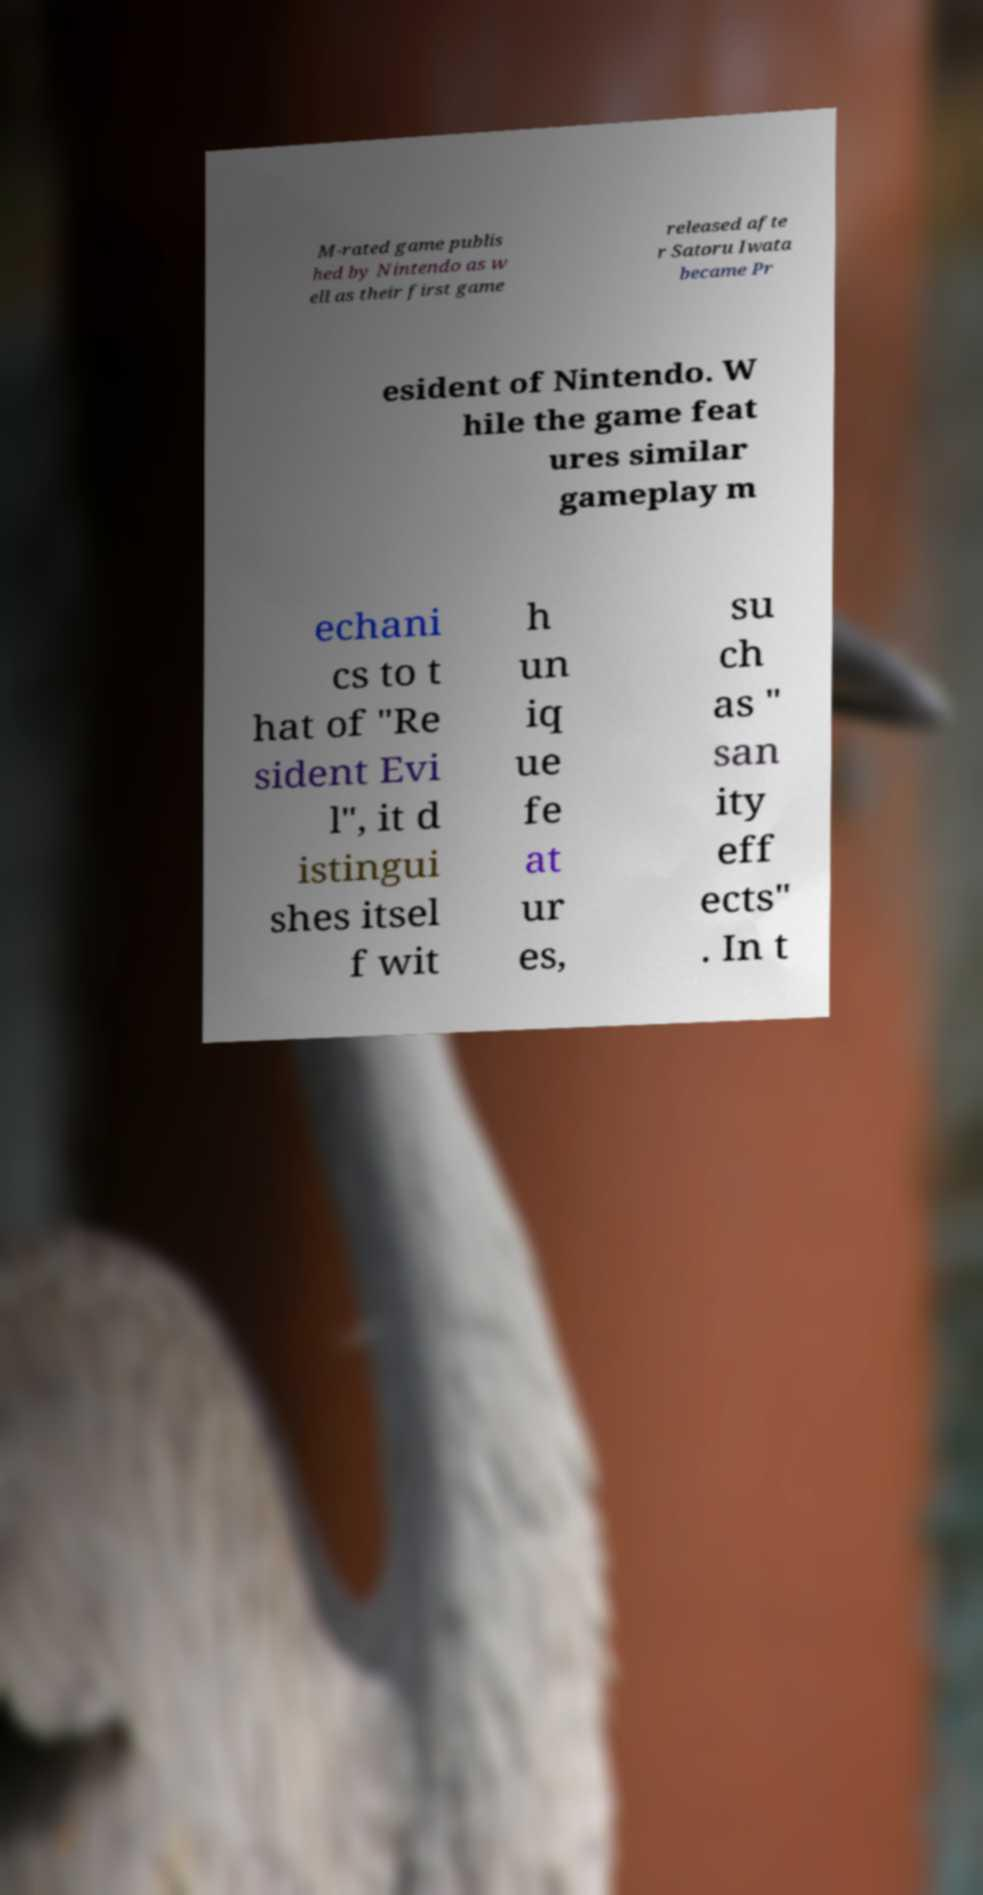I need the written content from this picture converted into text. Can you do that? M-rated game publis hed by Nintendo as w ell as their first game released afte r Satoru Iwata became Pr esident of Nintendo. W hile the game feat ures similar gameplay m echani cs to t hat of "Re sident Evi l", it d istingui shes itsel f wit h un iq ue fe at ur es, su ch as " san ity eff ects" . In t 